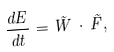<formula> <loc_0><loc_0><loc_500><loc_500>\frac { d E } { d t } = \vec { W } \, \cdot \, \vec { F } ,</formula> 